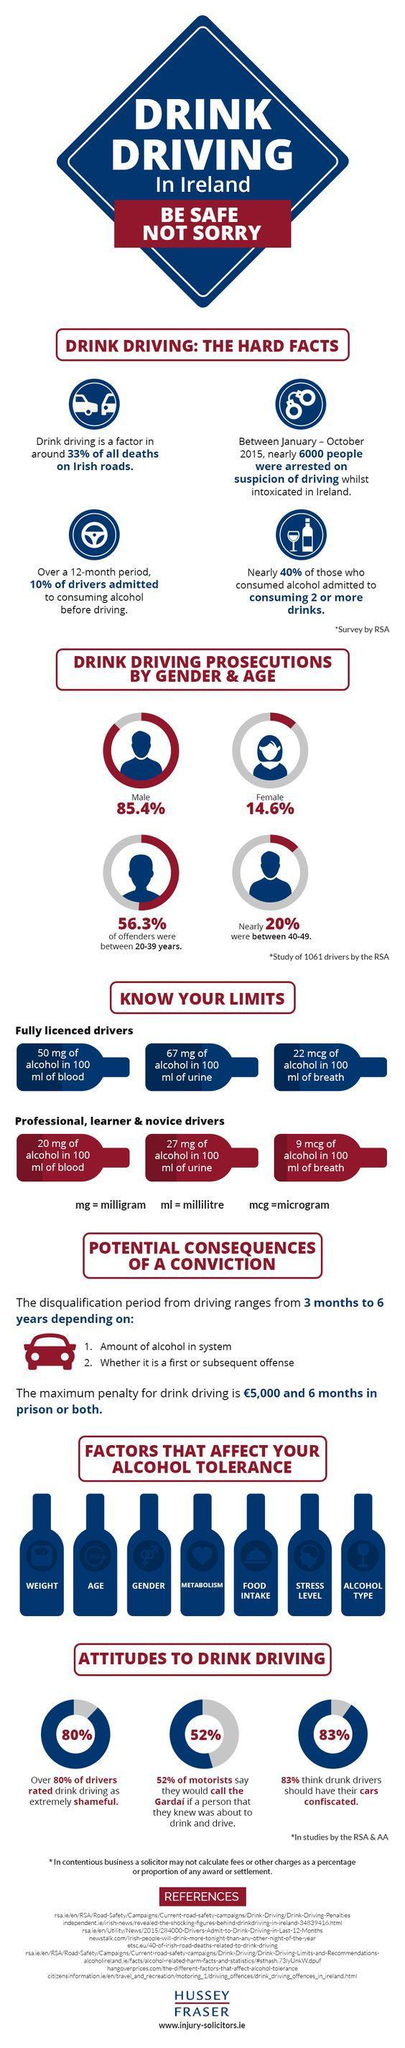What percentage of driver do not consider drunken driving as shameful activity?
Answer the question with a short phrase. 20% How many factors affect your alcohol tolerance? 7 What should be the level of alcohol in breath for licensed drivers, 50 mcg, 67 mcg, or 22 mcg? 22 mcg What should be the level of alcohol in urine for people learning to drive, 67 mg, 20 mg, or 27 mg? 27 mg 